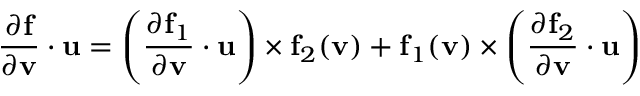<formula> <loc_0><loc_0><loc_500><loc_500>{ \frac { \partial f } { \partial v } } \cdot u = \left ( { \frac { \partial f _ { 1 } } { \partial v } } \cdot u \right ) \times f _ { 2 } ( v ) + f _ { 1 } ( v ) \times \left ( { \frac { \partial f _ { 2 } } { \partial v } } \cdot u \right )</formula> 